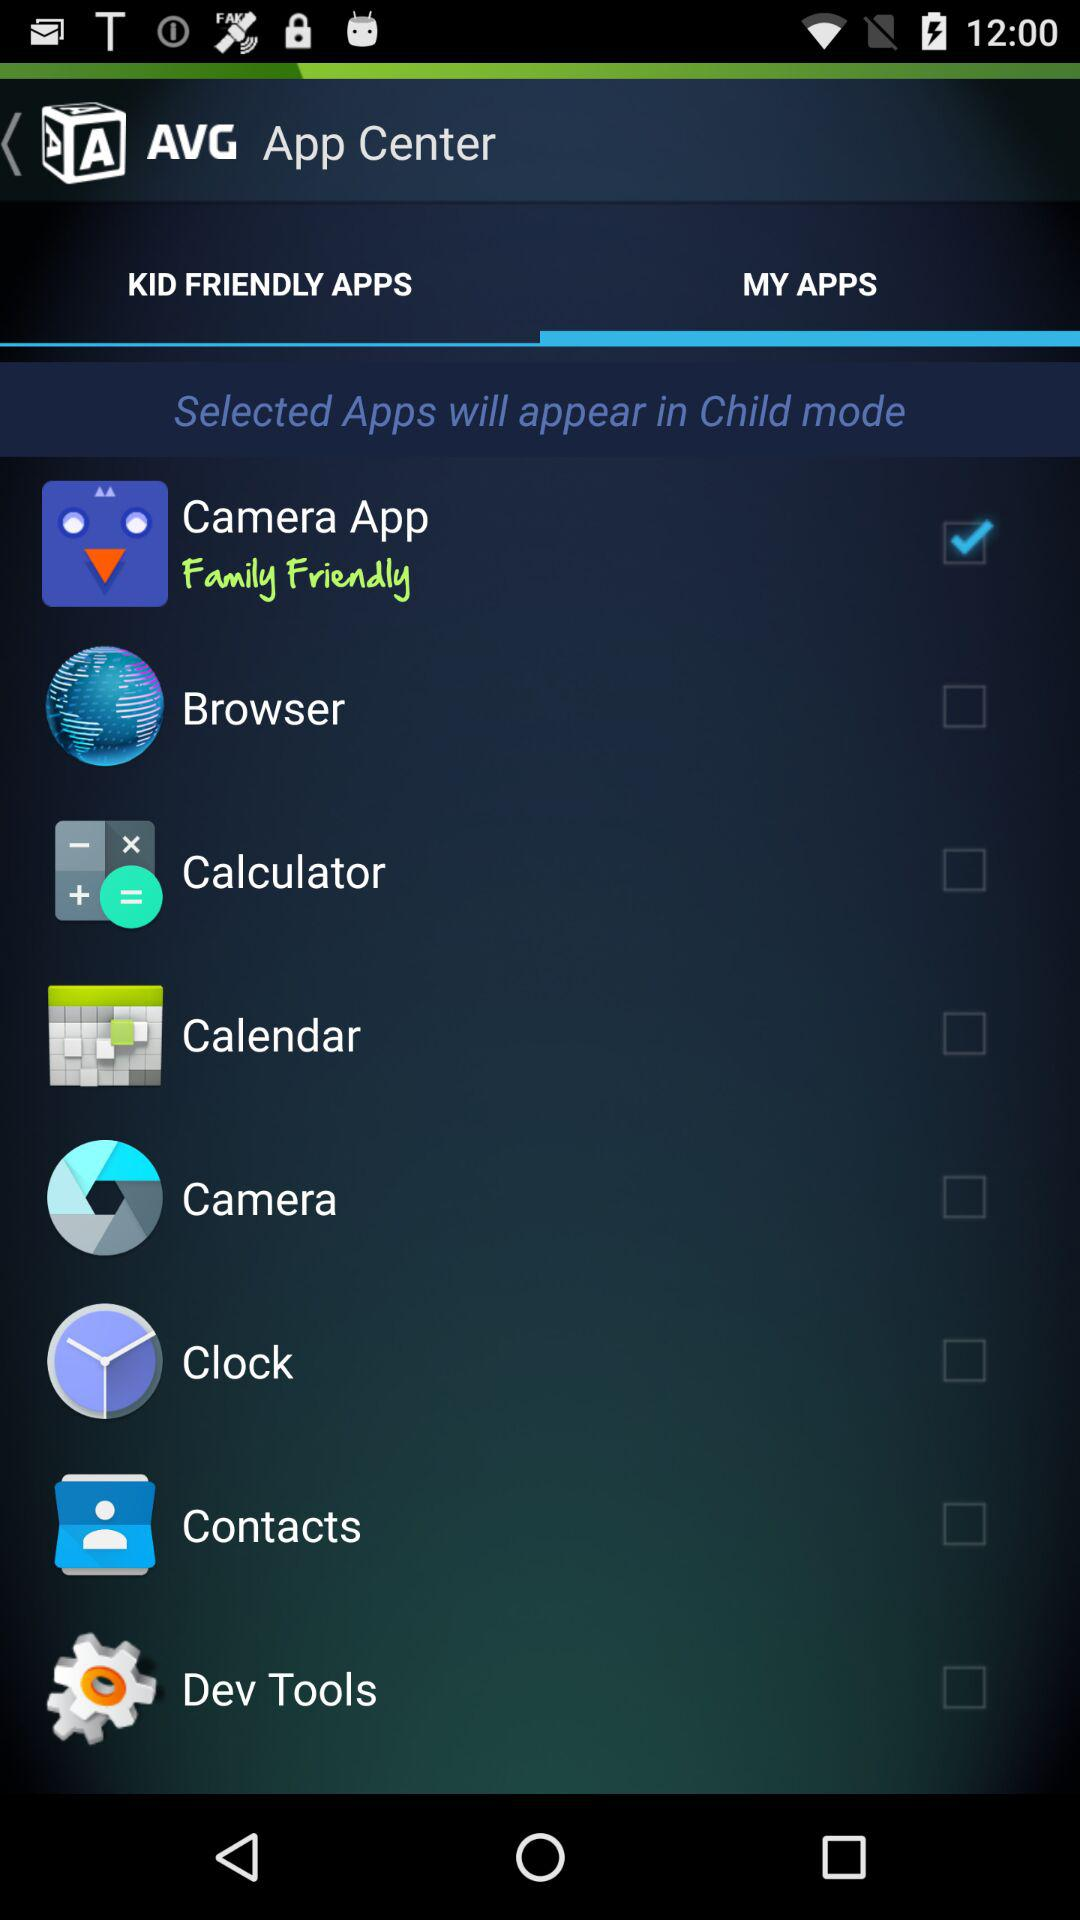Which app is selected? The selected app is "Camera App". 